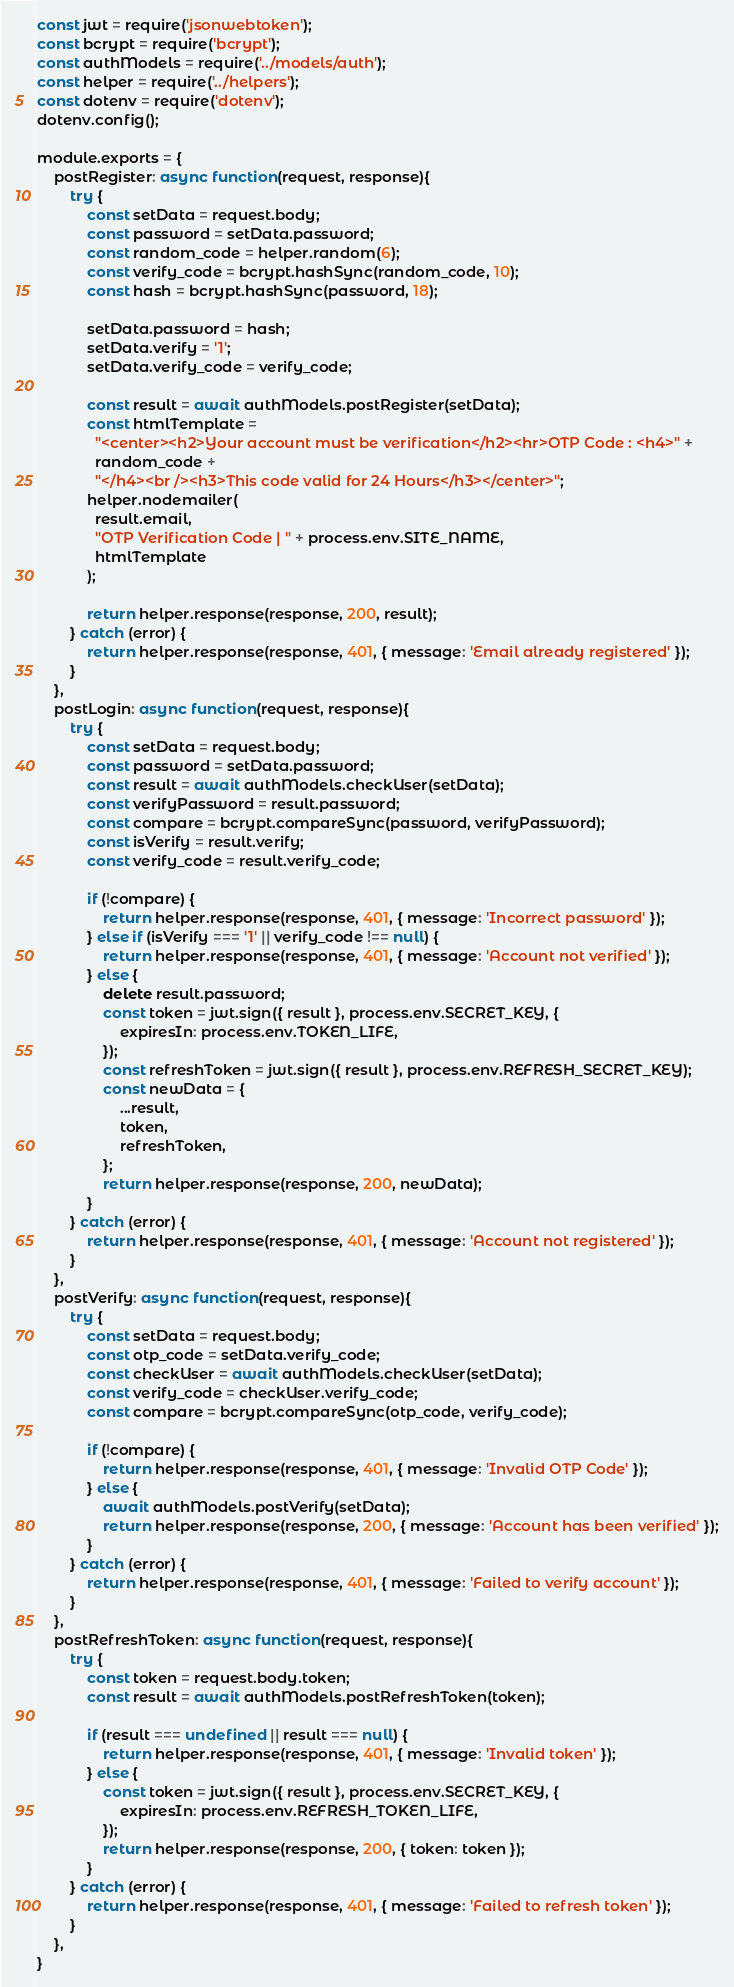<code> <loc_0><loc_0><loc_500><loc_500><_JavaScript_>const jwt = require('jsonwebtoken');
const bcrypt = require('bcrypt');
const authModels = require('../models/auth');
const helper = require('../helpers');
const dotenv = require('dotenv');
dotenv.config();

module.exports = {
    postRegister: async function(request, response){
        try {
            const setData = request.body;
            const password = setData.password;
            const random_code = helper.random(6);
            const verify_code = bcrypt.hashSync(random_code, 10);
            const hash = bcrypt.hashSync(password, 18);
            
            setData.password = hash;
            setData.verify = '1';
            setData.verify_code = verify_code;

            const result = await authModels.postRegister(setData);
            const htmlTemplate =
              "<center><h2>Your account must be verification</h2><hr>OTP Code : <h4>" +
              random_code +
              "</h4><br /><h3>This code valid for 24 Hours</h3></center>";
            helper.nodemailer(
              result.email,
              "OTP Verification Code | " + process.env.SITE_NAME,
              htmlTemplate
            );

            return helper.response(response, 200, result);
        } catch (error) {
            return helper.response(response, 401, { message: 'Email already registered' });
        }
    },
    postLogin: async function(request, response){
        try {
            const setData = request.body;
            const password = setData.password;
            const result = await authModels.checkUser(setData);
            const verifyPassword = result.password;
            const compare = bcrypt.compareSync(password, verifyPassword);
            const isVerify = result.verify;
            const verify_code = result.verify_code;

            if (!compare) {
                return helper.response(response, 401, { message: 'Incorrect password' });
            } else if (isVerify === '1' || verify_code !== null) {
                return helper.response(response, 401, { message: 'Account not verified' });
            } else {
                delete result.password;
                const token = jwt.sign({ result }, process.env.SECRET_KEY, {
                    expiresIn: process.env.TOKEN_LIFE,
                });
                const refreshToken = jwt.sign({ result }, process.env.REFRESH_SECRET_KEY);
                const newData = {
                    ...result,
                    token,
                    refreshToken,
                };
                return helper.response(response, 200, newData);
            }
        } catch (error) {
            return helper.response(response, 401, { message: 'Account not registered' });
        }
    },
    postVerify: async function(request, response){
        try {
            const setData = request.body;
            const otp_code = setData.verify_code;
            const checkUser = await authModels.checkUser(setData);
            const verify_code = checkUser.verify_code;
            const compare = bcrypt.compareSync(otp_code, verify_code);

            if (!compare) {
                return helper.response(response, 401, { message: 'Invalid OTP Code' });
            } else {
                await authModels.postVerify(setData);
                return helper.response(response, 200, { message: 'Account has been verified' });
            }
        } catch (error) {
            return helper.response(response, 401, { message: 'Failed to verify account' });
        }
    },
    postRefreshToken: async function(request, response){
        try {
            const token = request.body.token;
            const result = await authModels.postRefreshToken(token);

            if (result === undefined || result === null) {
                return helper.response(response, 401, { message: 'Invalid token' });
            } else {
                const token = jwt.sign({ result }, process.env.SECRET_KEY, {
                    expiresIn: process.env.REFRESH_TOKEN_LIFE,
                });
                return helper.response(response, 200, { token: token });
            }
        } catch (error) {
            return helper.response(response, 401, { message: 'Failed to refresh token' });
        }
    },
}
</code> 